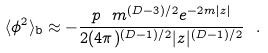Convert formula to latex. <formula><loc_0><loc_0><loc_500><loc_500>\langle \phi ^ { 2 } \rangle _ { \text {b} } \approx - \frac { p \ m ^ { ( D - 3 ) / 2 } e ^ { - 2 m | z | } } { 2 ( 4 \pi ) ^ { ( D - 1 ) / 2 } | z | ^ { ( D - 1 ) / 2 } } \ .</formula> 